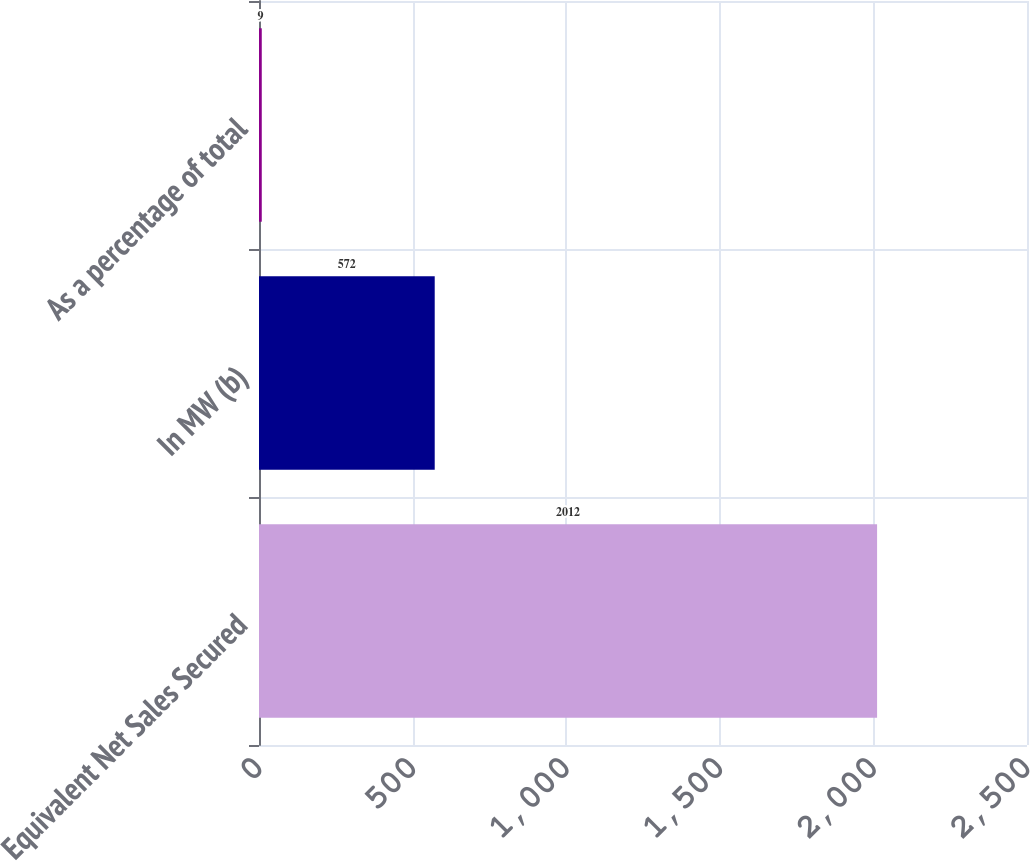Convert chart. <chart><loc_0><loc_0><loc_500><loc_500><bar_chart><fcel>Equivalent Net Sales Secured<fcel>In MW (b)<fcel>As a percentage of total<nl><fcel>2012<fcel>572<fcel>9<nl></chart> 